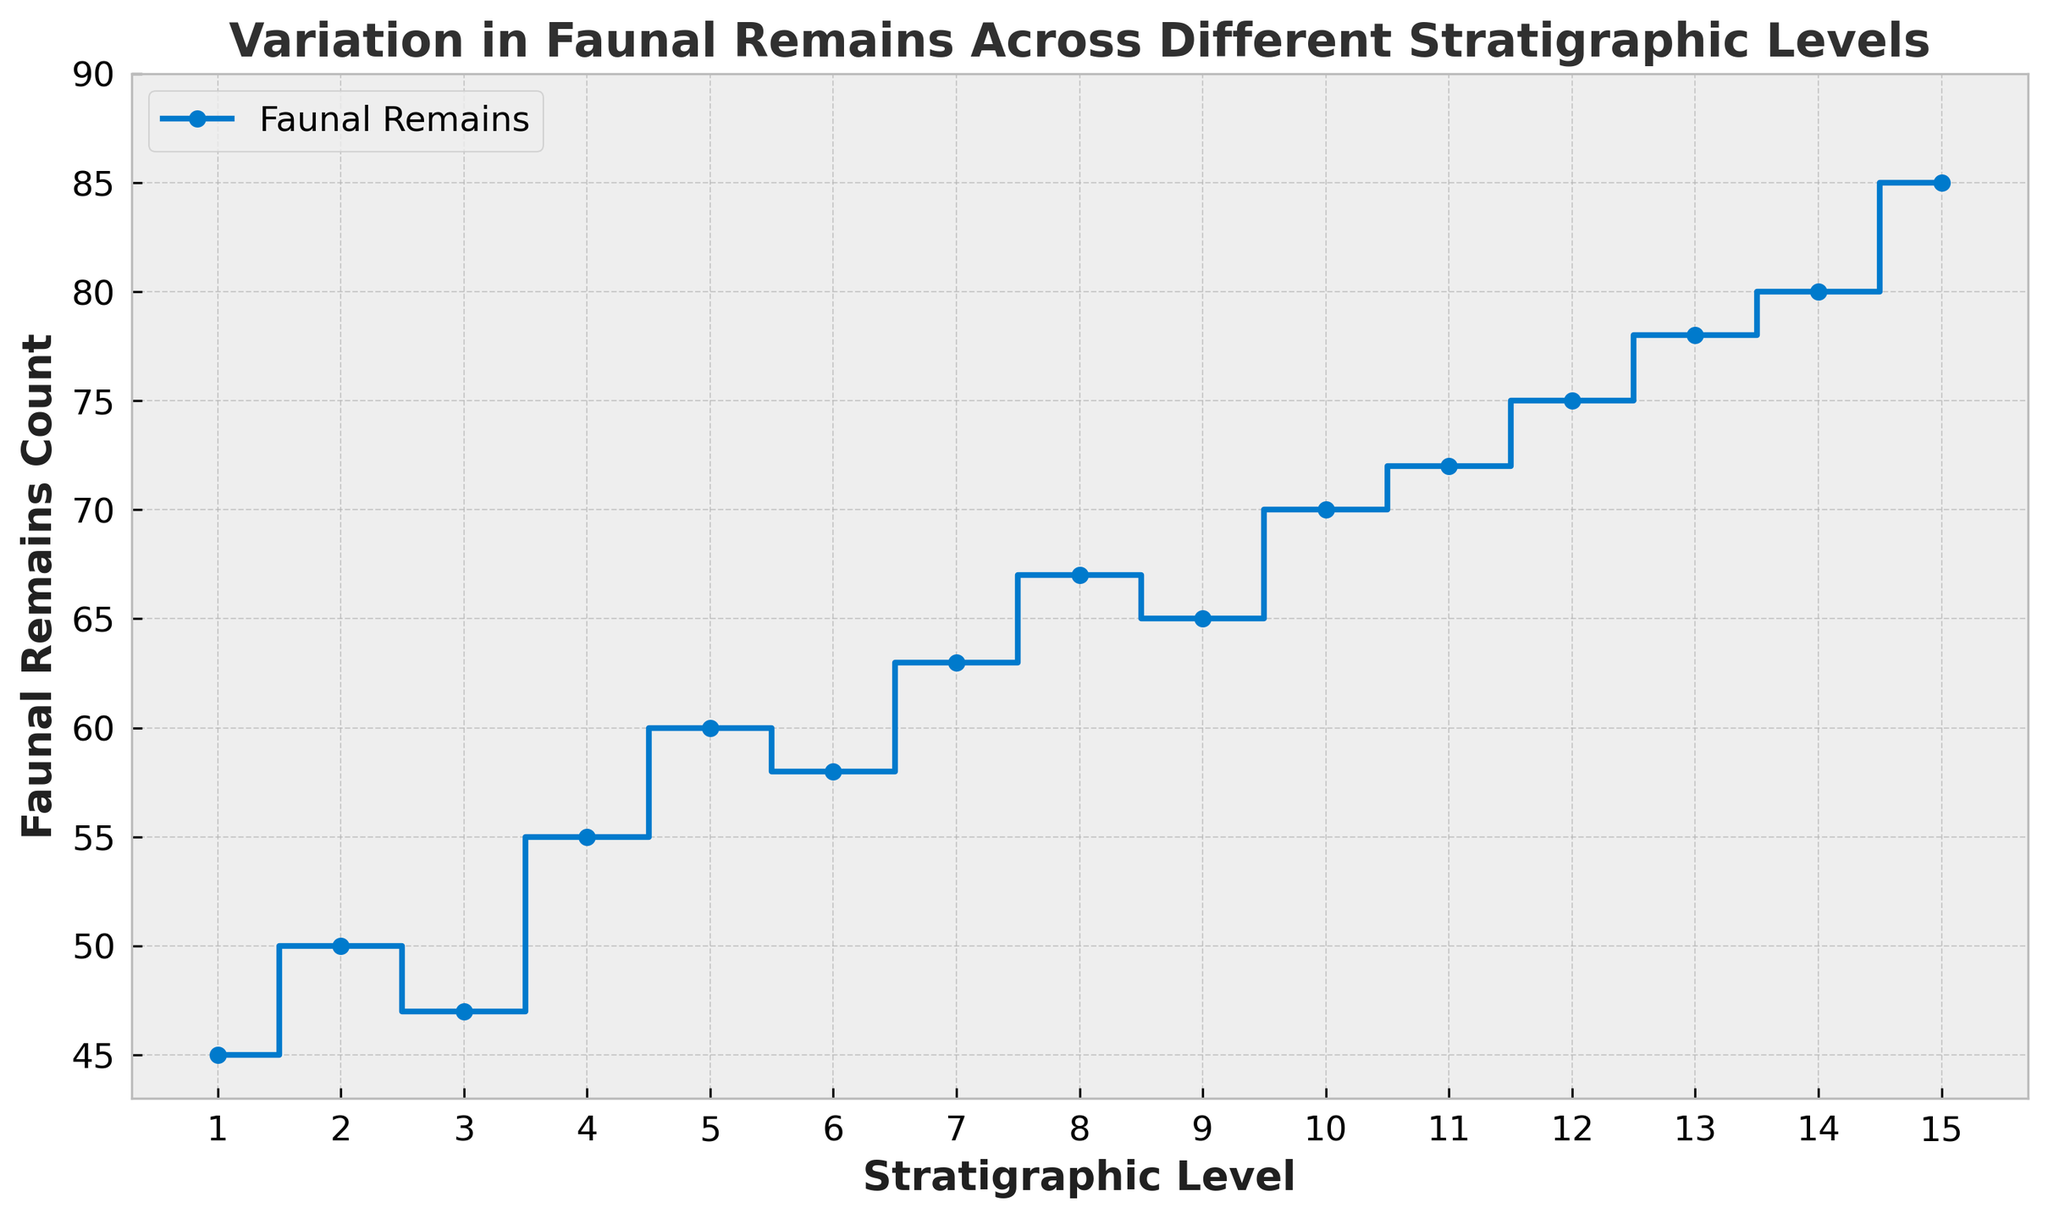What is the general trend in faunal remains across the stratigraphic levels? By observing the plot, the faunal remains count shows a consistent increase as the stratigraphic level increases. Initially, there are some small fluctuations, but overall, the trend is upward.
Answer: Increasing trend At which stratigraphic level is the faunal remains count the highest? The plot shows the highest faunal remains count at the highest visible point on the y-axis, which corresponds to stratigraphic level 15.
Answer: Level 15 Compare the faunal remains count at stratigraphic levels 5 and 10. Which one is higher? Referring to the plot, the faunal remains count at level 5 is 60, while at level 10, it is 70. Thus, level 10 has a higher count.
Answer: Level 10 What's the difference in the faunal remains count between stratigraphic levels 1 and 15? According to the plot, the faunal remains count at level 1 is 45, and at level 15, it is 85. The difference is calculated as 85 - 45.
Answer: 40 What is the average faunal remains count across all stratigraphic levels? To compute the average, sum all counts from levels 1 to 15 and divide by the number of levels. The total sum (45 + 50 + 47 + 55 + 60 + 58 + 63 + 67 + 65 + 70 + 72 + 75 + 78 + 80 + 85) is 970, and there are 15 levels. So, 970 / 15.
Answer: 64.67 Which stratigraphic level shows the first noticeable increase in faunal remains after an initial decline? By inspecting the plot, between levels 1 and 2, there's an increase, but between level 2 and level 3, there’s a slight decrease. The first noticeable increase after this is from level 3 to level 4.
Answer: Level 4 Is the count at stratigraphic level 7 more than twice the count at level 3? Checking the counts, level 7 has 63 faunal remains, and level 3 has 47. Twice the count at level 3 is 47 * 2 = 94, which is more than the count at level 7.
Answer: No By how much does the faunal remains count increase on average for each level from 1 to 15? To find the average increase per level, calculate the difference between the highest and lowest counts (85 - 45) and divide by the number of intervals (which is 14). The difference is 40, and dividing it by 14 gives the average increase.
Answer: 2.86 Which stratigraphic levels have faunal remains counts that are closer to the median of the dataset? The median for 15 data points is the value at the 8th position when sorted, which corresponds to the count at level 8, i.e., 67. Levels with counts close to 67 are 6, 7, 9, and 10, which have 58, 63, 65, and 70, respectively.
Answer: Levels 6, 7, 9, 10 Does any level show an exact count of 75 faunal remains? Observing the plot and matching counts, stratigraphic level 12 shows an exact count of 75 faunal remains.
Answer: Yes, level 12 